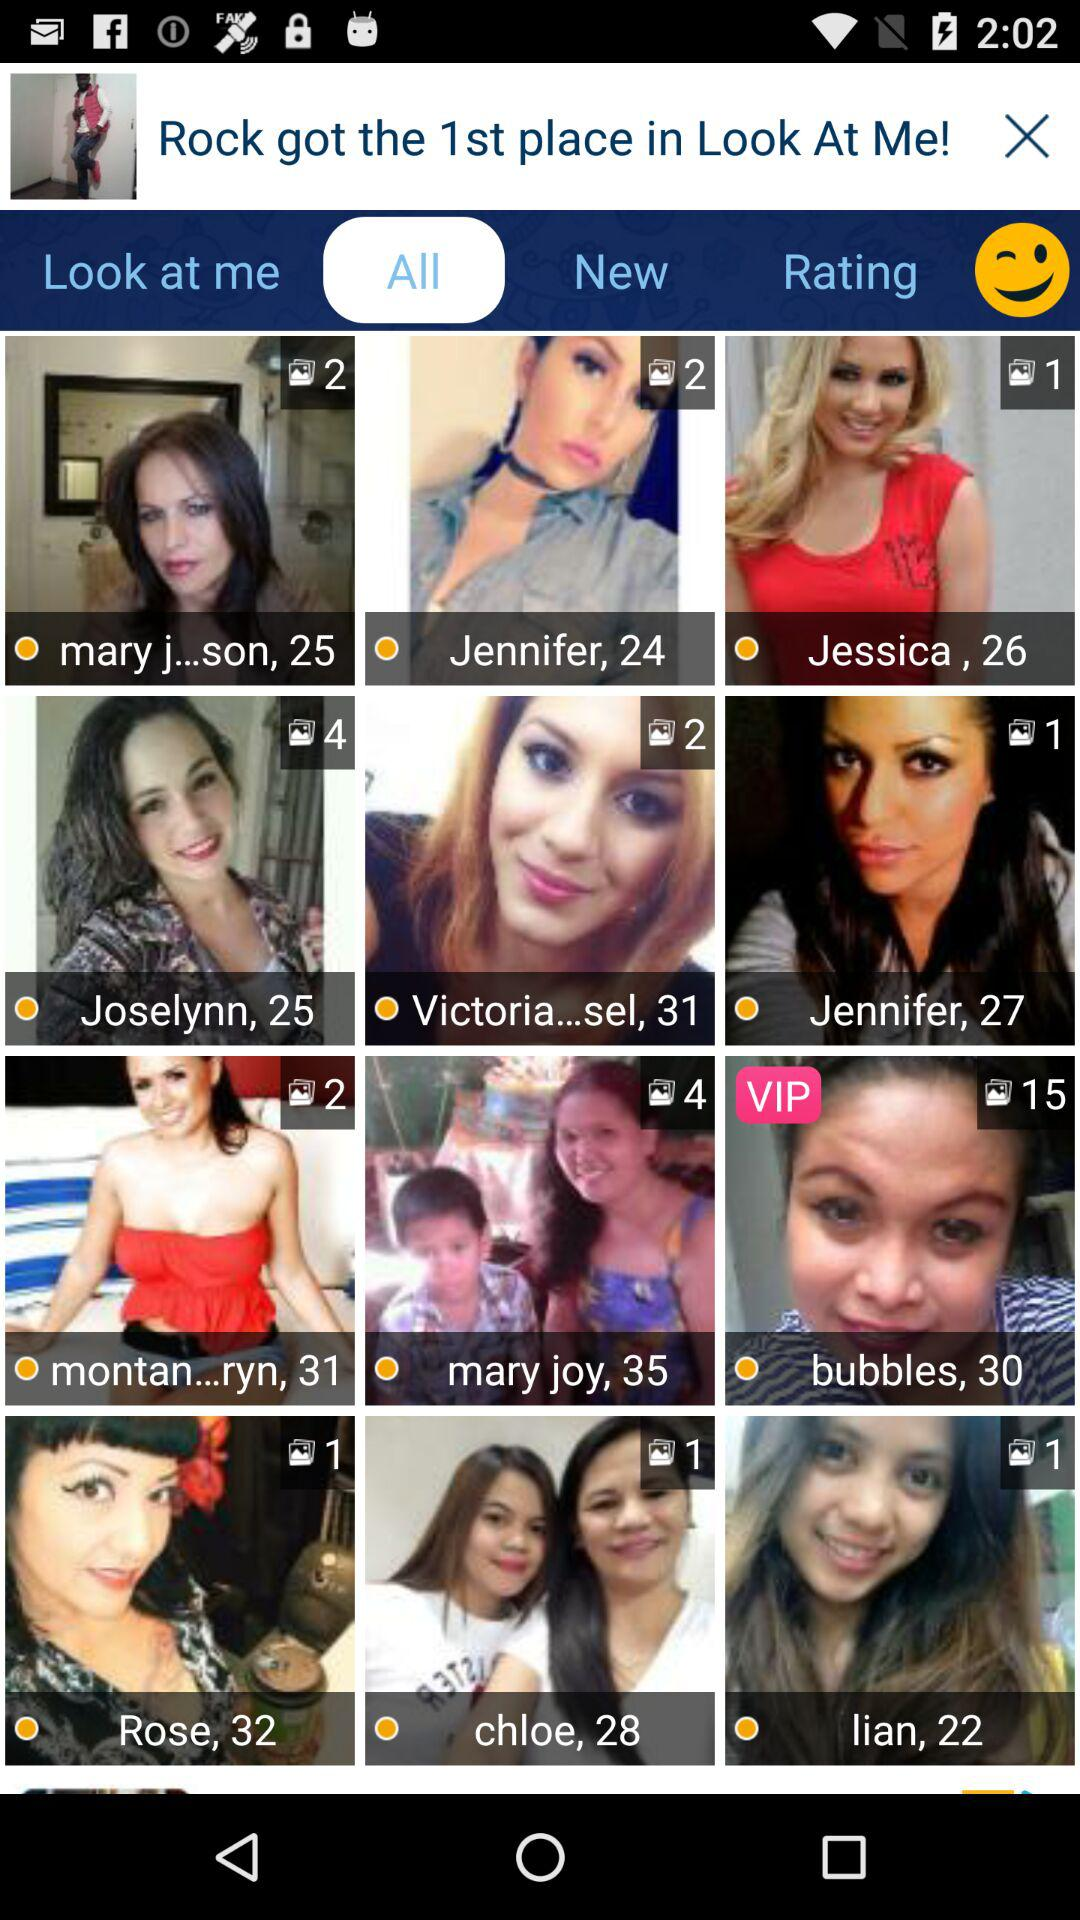How many photos of Lian are there? There is one photo of Lian. 